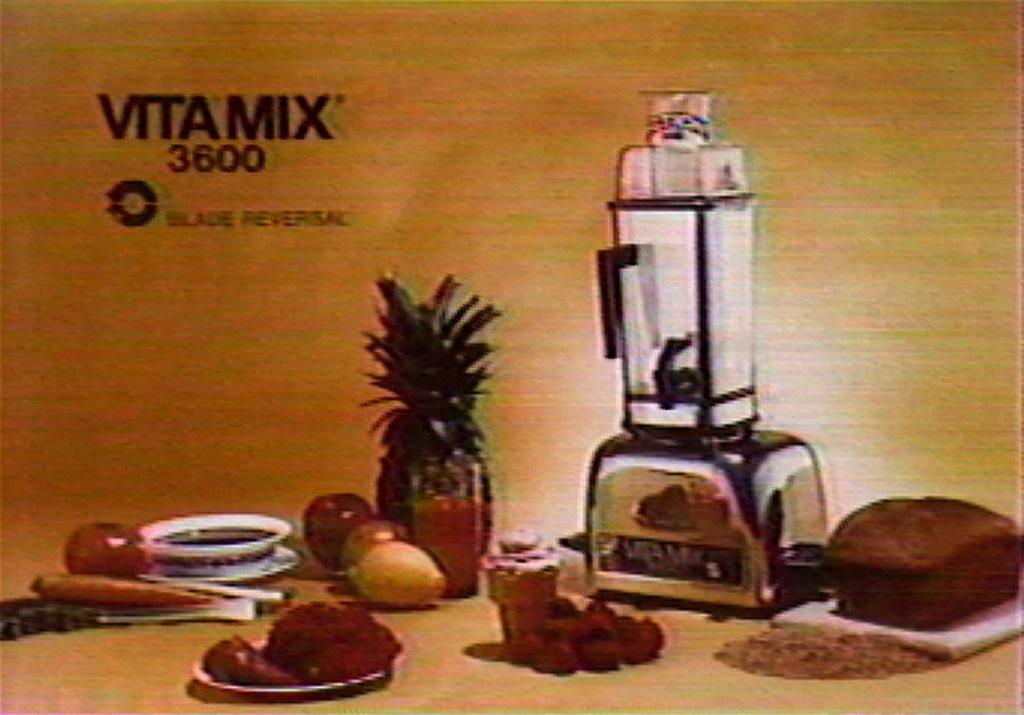<image>
Offer a succinct explanation of the picture presented. A picture of a blender called Vita Mix 